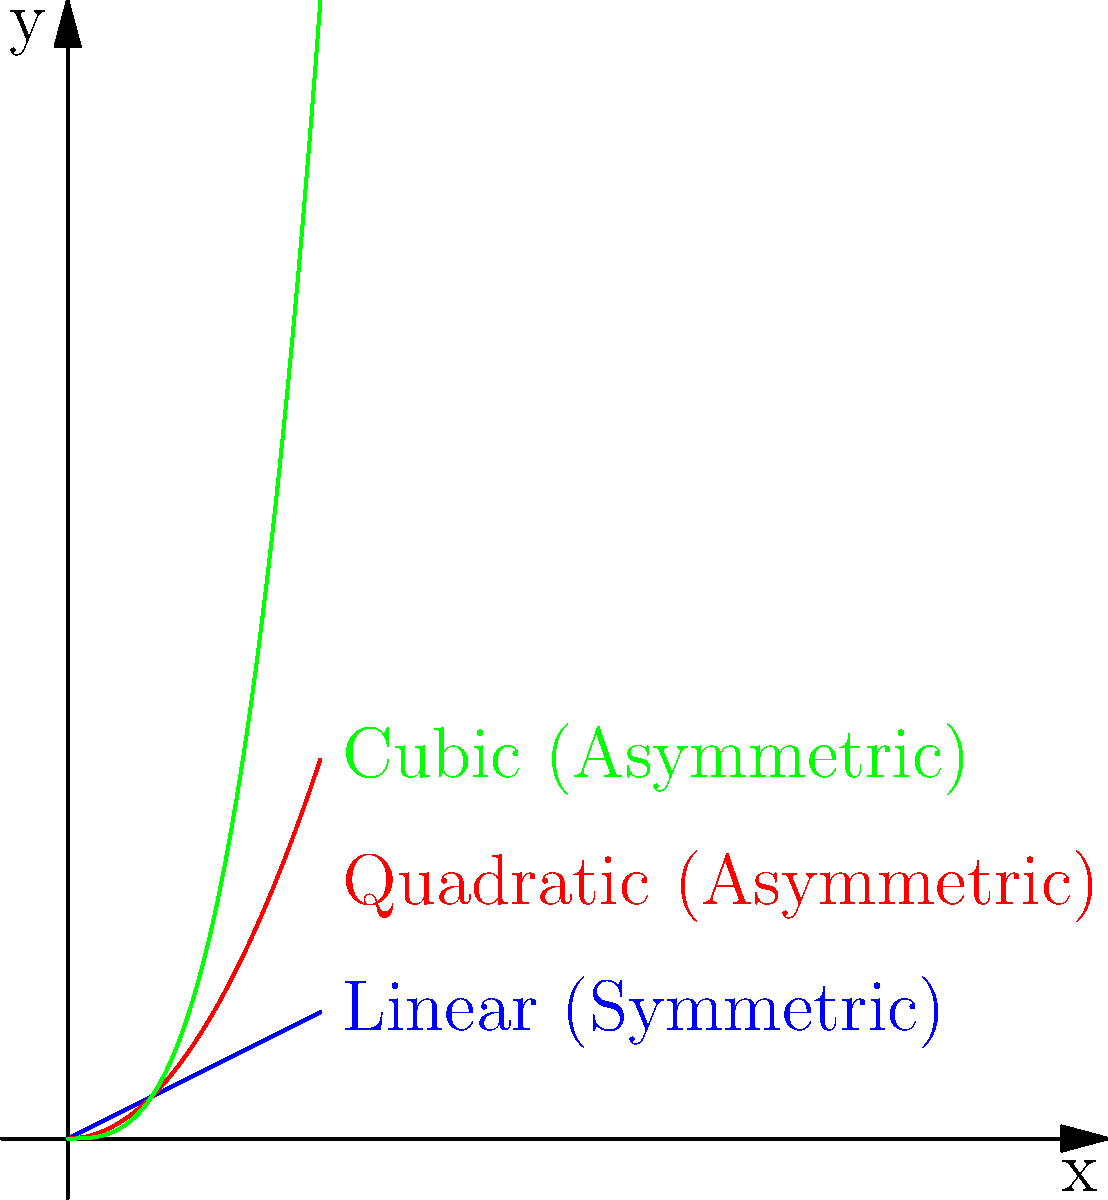As a cybersecurity professor, you often discuss the visual representations of encryption algorithms. Based on the graph shown, which type of encryption algorithm would likely correspond to the blue line, and why is this significant in terms of computational efficiency? Let's analyze this step-by-step:

1. Observe the graph:
   - Blue line: linear function (straight line)
   - Red line: quadratic function (parabola)
   - Green line: cubic function (S-shaped curve)

2. Characteristics of the blue line:
   - It's a straight line, representing a linear relationship between input (x) and output (y).
   - The slope is constant, indicating a consistent rate of change.

3. In cryptography, linear functions are often associated with symmetric encryption algorithms:
   - Symmetric algorithms use the same key for encryption and decryption.
   - They typically have a linear relationship between input size and encryption/decryption time.

4. Examples of symmetric algorithms:
   - AES (Advanced Encryption Standard)
   - DES (Data Encryption Standard)
   - Blowfish

5. Computational efficiency:
   - Linear algorithms generally have a time complexity of $O(n)$, where $n$ is the input size.
   - This means the time to encrypt or decrypt increases linearly with the size of the data.
   - Compared to asymmetric algorithms (often quadratic or higher), symmetric algorithms are much faster and more efficient for large data sets.

6. Significance in cybersecurity:
   - Symmetric algorithms are preferred for encrypting large amounts of data or for real-time communication due to their efficiency.
   - They are often used in combination with asymmetric algorithms in hybrid cryptosystems to leverage the strengths of both.
Answer: Symmetric encryption algorithm; linear time complexity ($O(n)$) enables efficient processing of large data sets. 